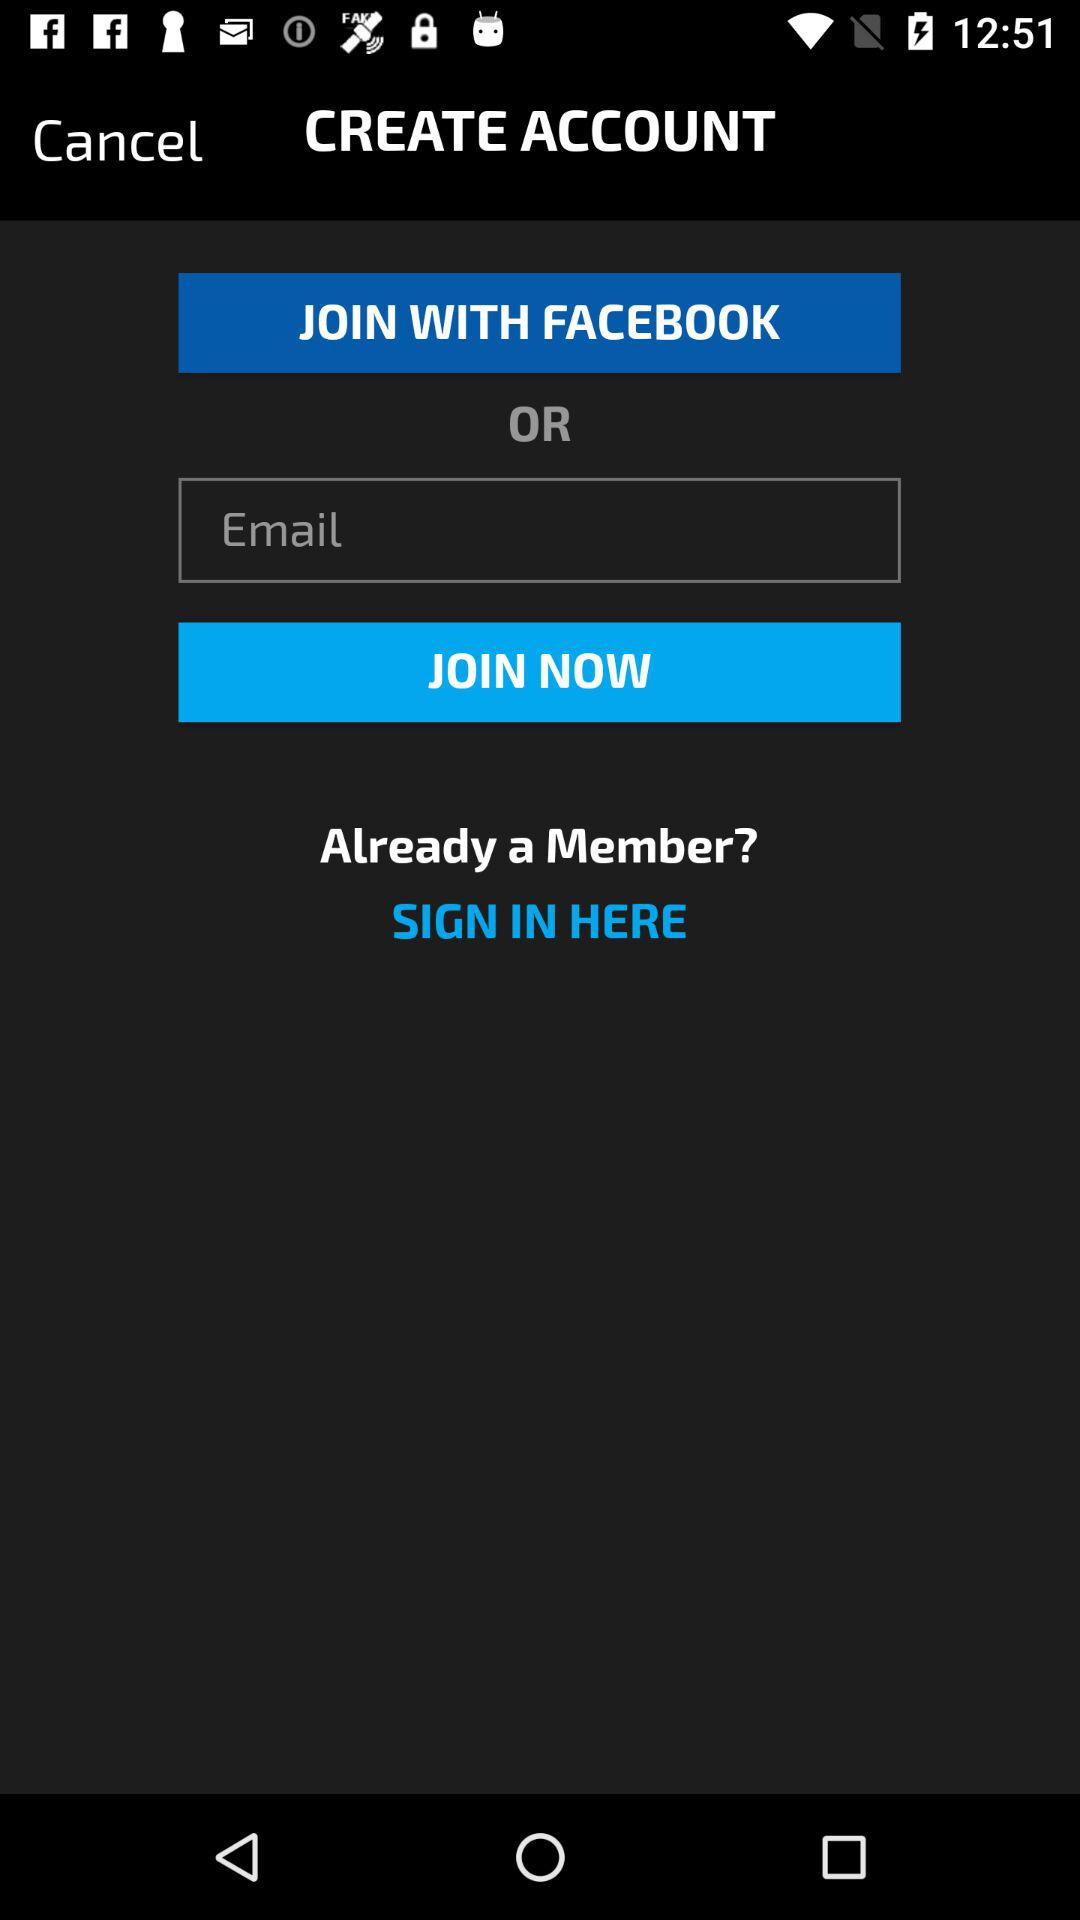What is the entered email address?
When the provided information is insufficient, respond with <no answer>. <no answer> 